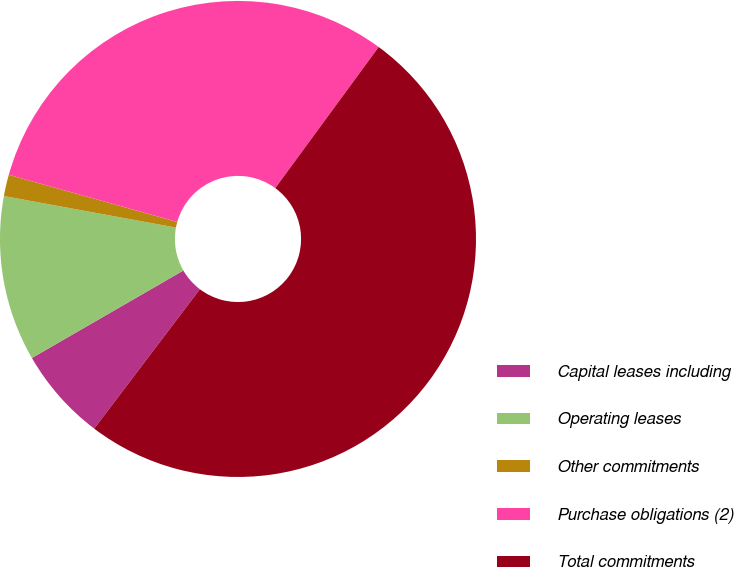Convert chart. <chart><loc_0><loc_0><loc_500><loc_500><pie_chart><fcel>Capital leases including<fcel>Operating leases<fcel>Other commitments<fcel>Purchase obligations (2)<fcel>Total commitments<nl><fcel>6.34%<fcel>11.22%<fcel>1.46%<fcel>30.72%<fcel>50.25%<nl></chart> 